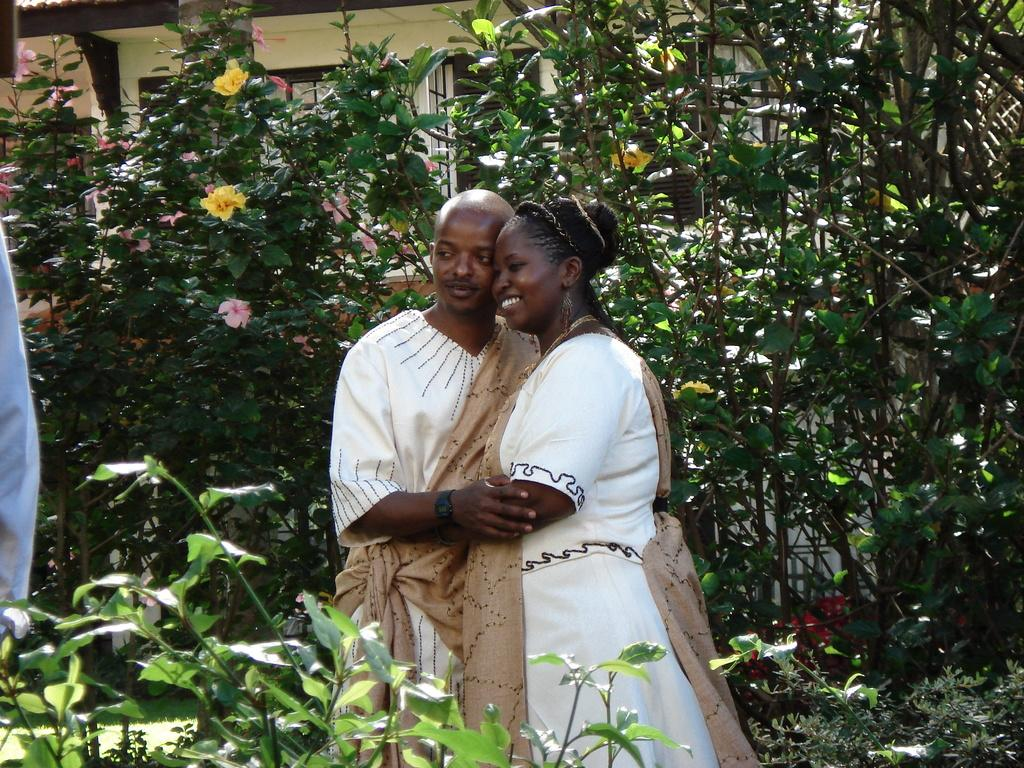What are the people in the image doing? The two people in the image are standing and smiling. What type of vegetation can be seen in the image? There are plants, trees, and flowers in the image. What is visible in the background of the image? There is a house in the background of the image. What is located on the left side of the image? There is cloth on the left side of the image. What type of volleyball game is being played in the image? There is no volleyball game present in the image. How does the behavior of the people in the image reflect their mood? The people in the image are standing and smiling, which suggests a positive mood, but we cannot determine their behavior beyond that from the image. 